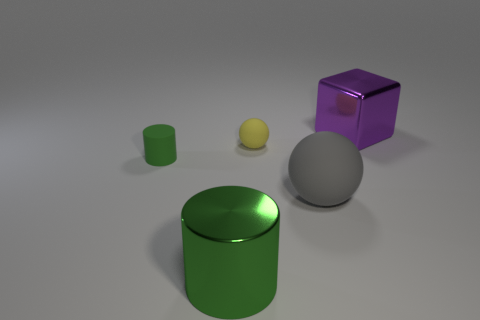Add 3 large green things. How many objects exist? 8 Subtract all cylinders. How many objects are left? 3 Add 1 small cylinders. How many small cylinders exist? 2 Subtract 0 gray blocks. How many objects are left? 5 Subtract all gray blocks. Subtract all yellow things. How many objects are left? 4 Add 2 big purple metallic objects. How many big purple metallic objects are left? 3 